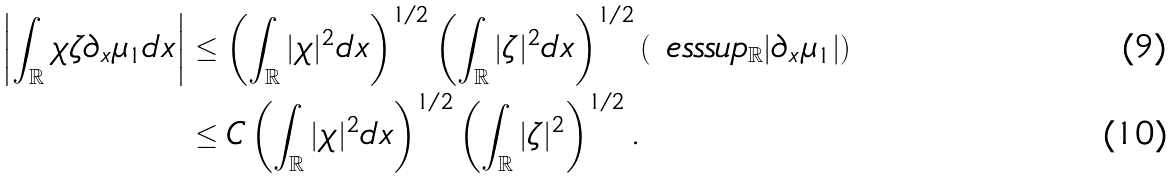<formula> <loc_0><loc_0><loc_500><loc_500>\left | \int _ { \mathbb { R } } \chi \zeta \partial _ { x } \mu _ { 1 } d x \right | & \leq \left ( \int _ { \mathbb { R } } | \chi | ^ { 2 } d x \right ) ^ { 1 / 2 } \left ( \int _ { \mathbb { R } } | \zeta | ^ { 2 } d x \right ) ^ { 1 / 2 } \left ( \ e s s s u p _ { \mathbb { R } } | \partial _ { x } \mu _ { 1 } | \right ) \\ & \leq C \left ( \int _ { \mathbb { R } } | \chi | ^ { 2 } d x \right ) ^ { 1 / 2 } \left ( \int _ { \mathbb { R } } | \zeta | ^ { 2 } \right ) ^ { 1 / 2 } .</formula> 